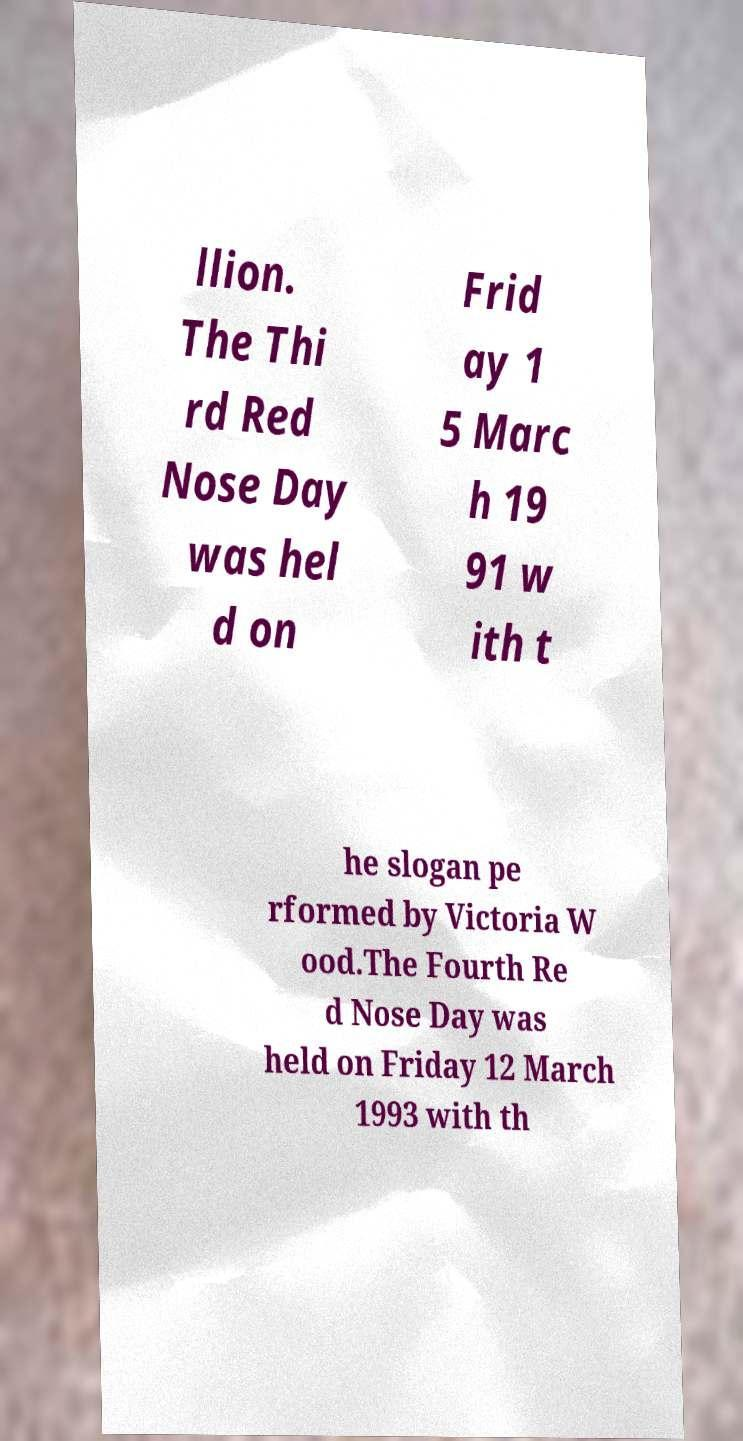There's text embedded in this image that I need extracted. Can you transcribe it verbatim? llion. The Thi rd Red Nose Day was hel d on Frid ay 1 5 Marc h 19 91 w ith t he slogan pe rformed by Victoria W ood.The Fourth Re d Nose Day was held on Friday 12 March 1993 with th 